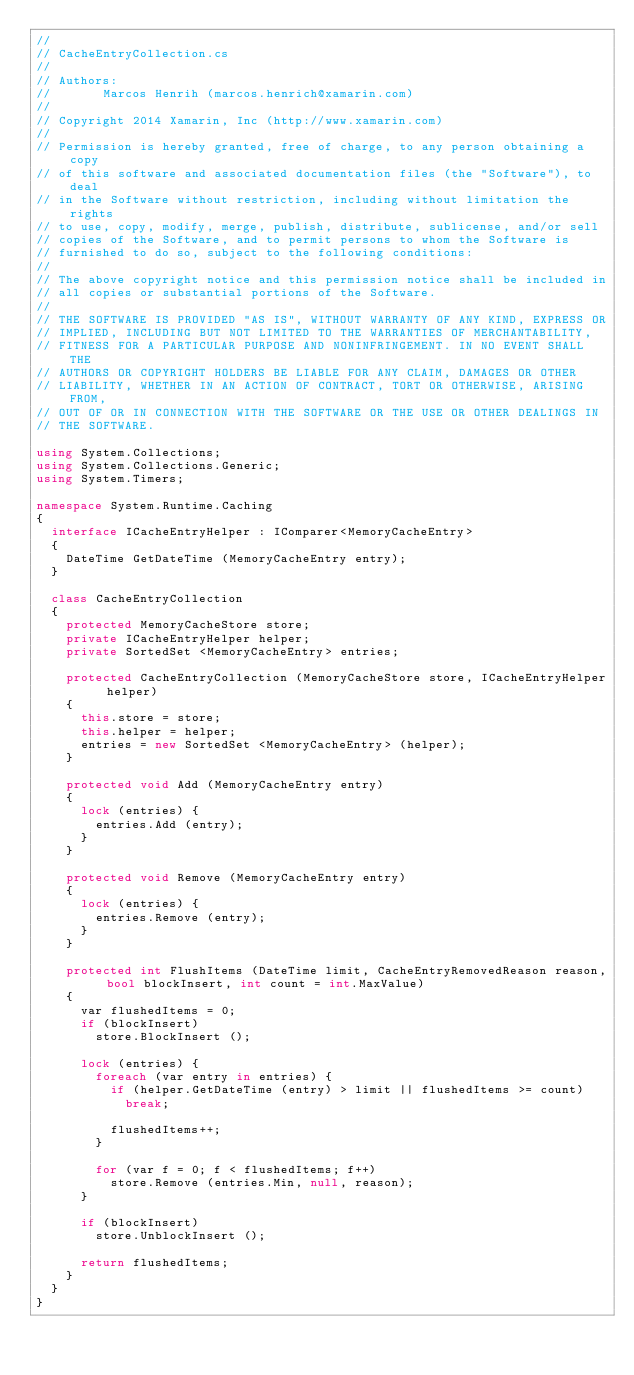Convert code to text. <code><loc_0><loc_0><loc_500><loc_500><_C#_>//
// CacheEntryCollection.cs
//
// Authors:
//       Marcos Henrih (marcos.henrich@xamarin.com)
//
// Copyright 2014 Xamarin, Inc (http://www.xamarin.com)
//
// Permission is hereby granted, free of charge, to any person obtaining a copy
// of this software and associated documentation files (the "Software"), to deal
// in the Software without restriction, including without limitation the rights
// to use, copy, modify, merge, publish, distribute, sublicense, and/or sell
// copies of the Software, and to permit persons to whom the Software is
// furnished to do so, subject to the following conditions:
//
// The above copyright notice and this permission notice shall be included in
// all copies or substantial portions of the Software.
//
// THE SOFTWARE IS PROVIDED "AS IS", WITHOUT WARRANTY OF ANY KIND, EXPRESS OR
// IMPLIED, INCLUDING BUT NOT LIMITED TO THE WARRANTIES OF MERCHANTABILITY,
// FITNESS FOR A PARTICULAR PURPOSE AND NONINFRINGEMENT. IN NO EVENT SHALL THE
// AUTHORS OR COPYRIGHT HOLDERS BE LIABLE FOR ANY CLAIM, DAMAGES OR OTHER
// LIABILITY, WHETHER IN AN ACTION OF CONTRACT, TORT OR OTHERWISE, ARISING FROM,
// OUT OF OR IN CONNECTION WITH THE SOFTWARE OR THE USE OR OTHER DEALINGS IN
// THE SOFTWARE.

using System.Collections;
using System.Collections.Generic;
using System.Timers;

namespace System.Runtime.Caching
{
	interface ICacheEntryHelper : IComparer<MemoryCacheEntry>
	{
		DateTime GetDateTime (MemoryCacheEntry entry);
	}

	class CacheEntryCollection
	{
		protected MemoryCacheStore store;
		private ICacheEntryHelper helper;
		private SortedSet <MemoryCacheEntry> entries;

		protected CacheEntryCollection (MemoryCacheStore store, ICacheEntryHelper helper)
		{
			this.store = store;
			this.helper = helper;
			entries = new SortedSet <MemoryCacheEntry> (helper);
		}

		protected void Add (MemoryCacheEntry entry)
		{
			lock (entries) {
				entries.Add (entry);
			}
		}

		protected void Remove (MemoryCacheEntry entry)
		{
			lock (entries) {
				entries.Remove (entry);
			}
		}

		protected int FlushItems (DateTime limit, CacheEntryRemovedReason reason, bool blockInsert, int count = int.MaxValue)
		{
			var flushedItems = 0;
			if (blockInsert)
				store.BlockInsert ();

			lock (entries) {
				foreach (var entry in entries) {
					if (helper.GetDateTime (entry) > limit || flushedItems >= count)
						break;

					flushedItems++;
				}

				for (var f = 0; f < flushedItems; f++)
					store.Remove (entries.Min, null, reason);
			}

			if (blockInsert)
				store.UnblockInsert ();

			return flushedItems;
		}
	}
}</code> 